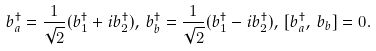Convert formula to latex. <formula><loc_0><loc_0><loc_500><loc_500>b ^ { \dag } _ { a } = \frac { 1 } { \sqrt { 2 } } ( b ^ { \dag } _ { 1 } + i b ^ { \dag } _ { 2 } ) , \, b ^ { \dag } _ { b } = \frac { 1 } { \sqrt { 2 } } ( b ^ { \dag } _ { 1 } - i b ^ { \dag } _ { 2 } ) , \, [ b ^ { \dag } _ { a } , \, b _ { b } ] = 0 .</formula> 